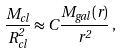Convert formula to latex. <formula><loc_0><loc_0><loc_500><loc_500>\frac { M _ { c l } } { R ^ { 2 } _ { c l } } \approx C \frac { M _ { g a l } ( r ) } { r ^ { 2 } } \, ,</formula> 